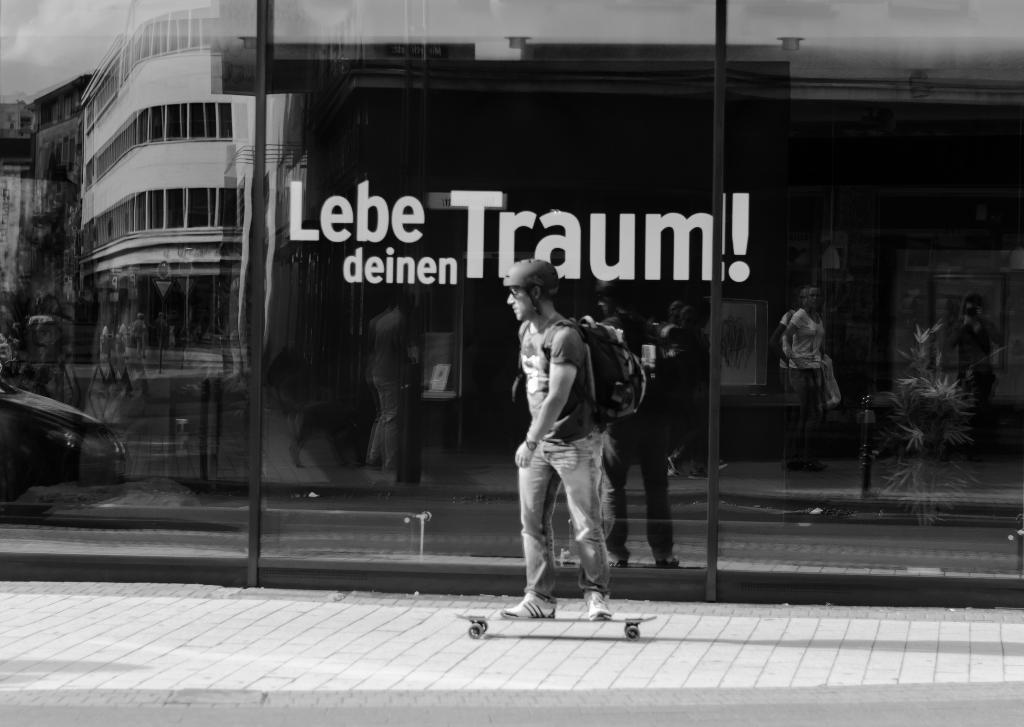What is the man in the image doing? The man is skating. What can be seen in the background of the image? There is a glass wall in the background of the image. Is there anything on the glass wall? Yes, there is a sticker on the glass wall. What type of beef can be seen on the ground in the image? There is no beef or ground present in the image. 